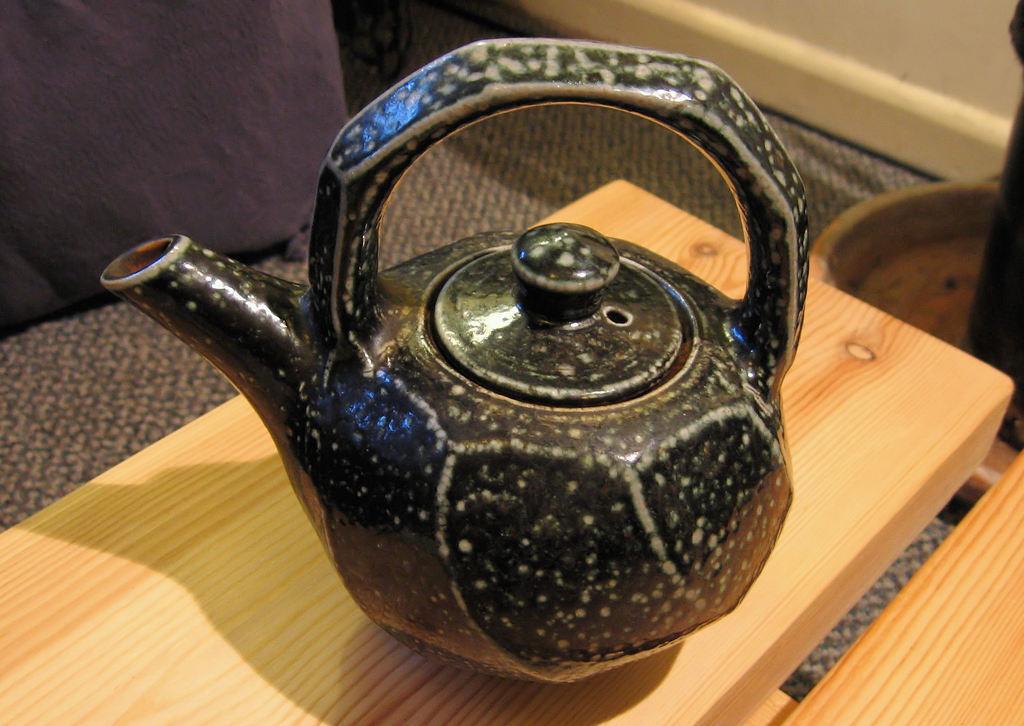Describe this image in one or two sentences. In the image we can see there is table on which there is a kettle kept which is in black colour. 